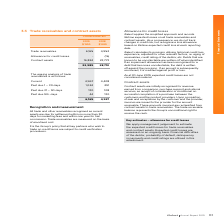According to Iselect's financial document, How are trade receivables measured? on the basis of amortised cost. The document states: "trail commission. Trade receivables are measured on the basis of amortised cost...." Also, How does the Company recognise a loss allowance? based on lifetime expected credit loss at each reporting date. The document states: "es in credit risk, but recognise a loss allowance based on lifetime expected credit loss at each reporting date...." Also, How does the Company calculate its provision? utilising historical credit loss experience, adjusted for other relevant factors, i.e. aging of receivables, credit rating of the debtor, etc.. The document states: "iSelect calculates its provision utilising historical credit loss experience, adjusted for other relevant factors, i.e. aging of receivables, credit r..." Also, can you calculate: What is the percentage change in the trade receivables from 2018 to 2019? To answer this question, I need to perform calculations using the financial data. The calculation is: (6,165-4,952)/4,952, which equals 24.5 (percentage). This is based on the information: "Trade receivables 6,165 4,952 Trade receivables 6,165 4,952..." The key data points involved are: 4,952, 6,165. Also, can you calculate: What is the percentage change in the contract assets from 2018 to 2019? To answer this question, I need to perform calculations using the financial data. The calculation is: (16,824-23,773)/23,773, which equals -29.23 (percentage). This is based on the information: "Contract assets 16,824 23,773 Contract assets 16,824 23,773..." The key data points involved are: 16,824, 23,773. Also, can you calculate: What is the percentage change in the trade receivables past due 90+ days from 2018 to 2019? To answer this question, I need to perform calculations using the financial data. The calculation is: (44-130)/130, which equals -66.15 (percentage). This is based on the information: "Past due 90+ days 44 130 Past due 90+ days 44 130..." The key data points involved are: 130, 44. 